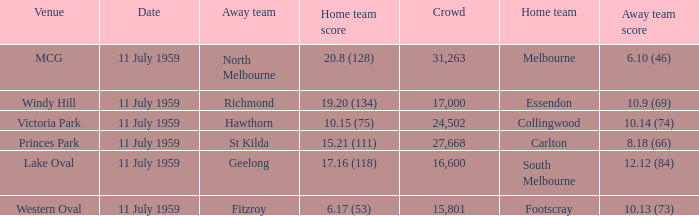How many points does footscray score as the home side? 6.17 (53). 